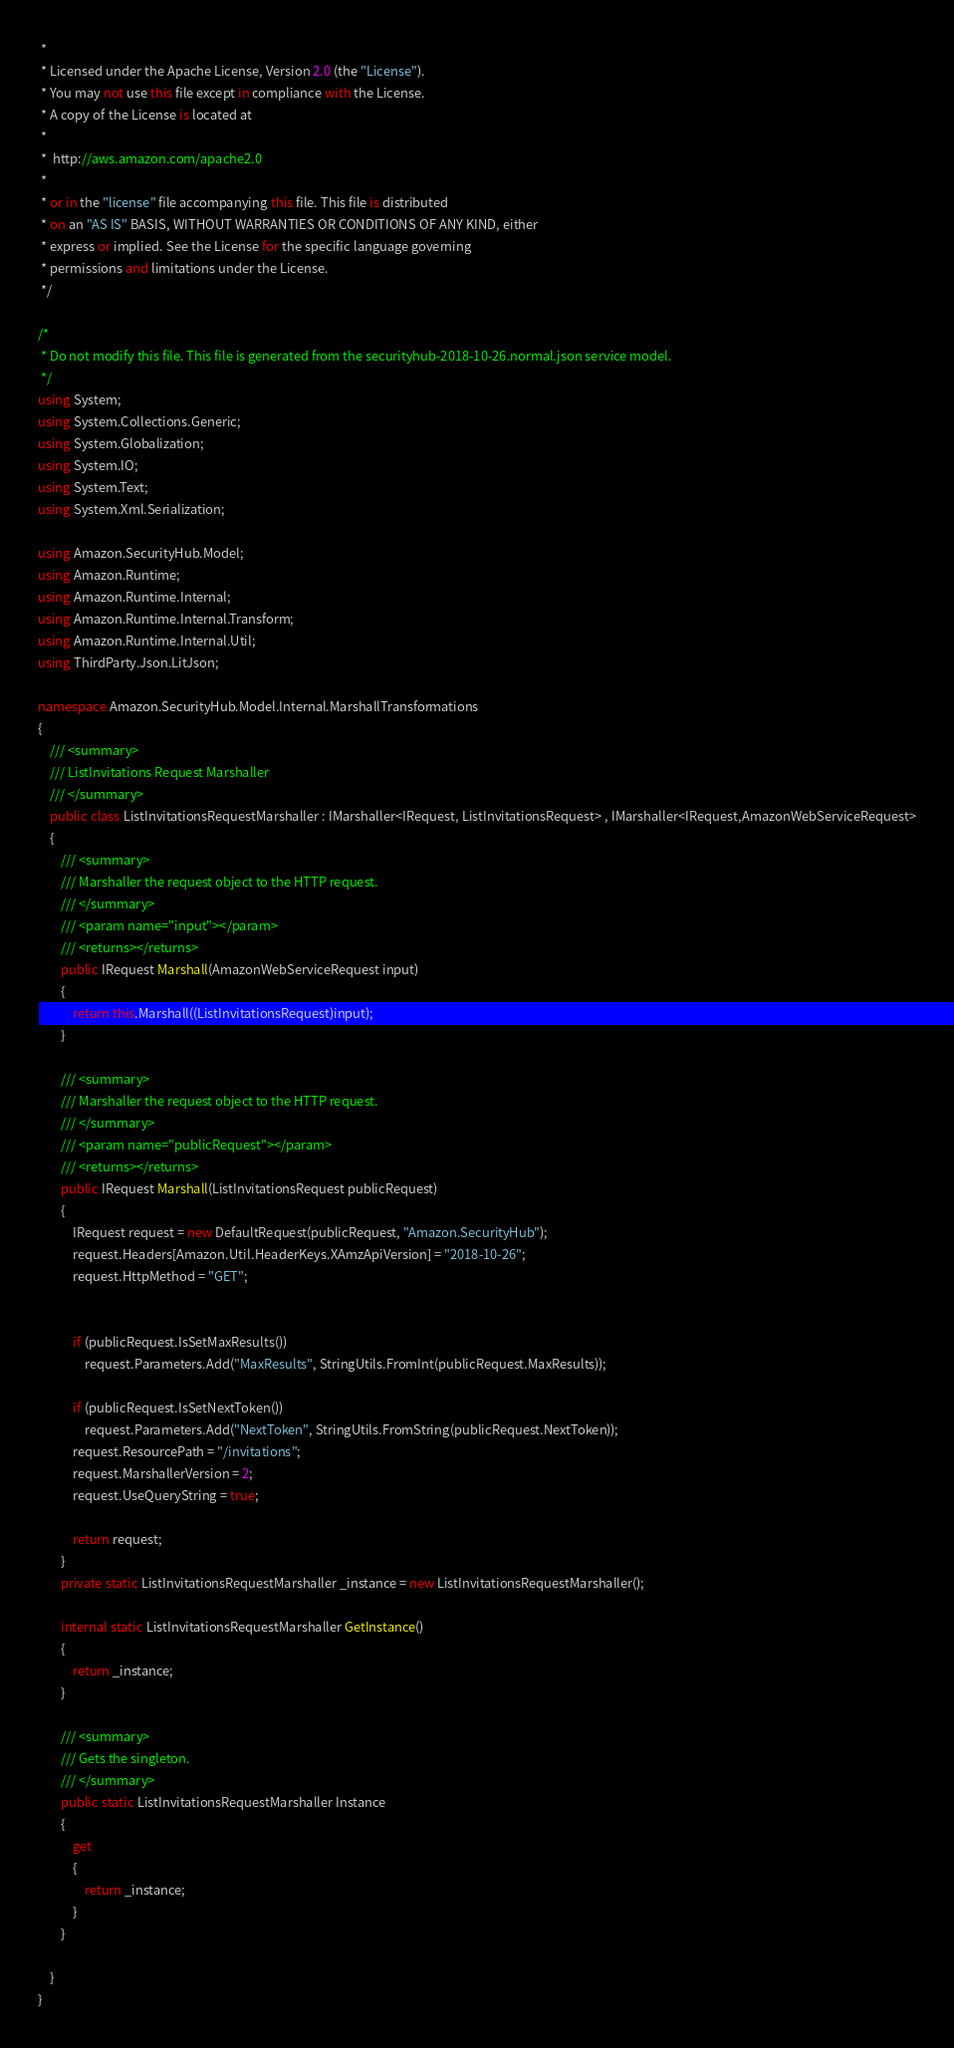Convert code to text. <code><loc_0><loc_0><loc_500><loc_500><_C#_> * 
 * Licensed under the Apache License, Version 2.0 (the "License").
 * You may not use this file except in compliance with the License.
 * A copy of the License is located at
 * 
 *  http://aws.amazon.com/apache2.0
 * 
 * or in the "license" file accompanying this file. This file is distributed
 * on an "AS IS" BASIS, WITHOUT WARRANTIES OR CONDITIONS OF ANY KIND, either
 * express or implied. See the License for the specific language governing
 * permissions and limitations under the License.
 */

/*
 * Do not modify this file. This file is generated from the securityhub-2018-10-26.normal.json service model.
 */
using System;
using System.Collections.Generic;
using System.Globalization;
using System.IO;
using System.Text;
using System.Xml.Serialization;

using Amazon.SecurityHub.Model;
using Amazon.Runtime;
using Amazon.Runtime.Internal;
using Amazon.Runtime.Internal.Transform;
using Amazon.Runtime.Internal.Util;
using ThirdParty.Json.LitJson;

namespace Amazon.SecurityHub.Model.Internal.MarshallTransformations
{
    /// <summary>
    /// ListInvitations Request Marshaller
    /// </summary>       
    public class ListInvitationsRequestMarshaller : IMarshaller<IRequest, ListInvitationsRequest> , IMarshaller<IRequest,AmazonWebServiceRequest>
    {
        /// <summary>
        /// Marshaller the request object to the HTTP request.
        /// </summary>  
        /// <param name="input"></param>
        /// <returns></returns>
        public IRequest Marshall(AmazonWebServiceRequest input)
        {
            return this.Marshall((ListInvitationsRequest)input);
        }

        /// <summary>
        /// Marshaller the request object to the HTTP request.
        /// </summary>  
        /// <param name="publicRequest"></param>
        /// <returns></returns>
        public IRequest Marshall(ListInvitationsRequest publicRequest)
        {
            IRequest request = new DefaultRequest(publicRequest, "Amazon.SecurityHub");
            request.Headers[Amazon.Util.HeaderKeys.XAmzApiVersion] = "2018-10-26";            
            request.HttpMethod = "GET";

            
            if (publicRequest.IsSetMaxResults())
                request.Parameters.Add("MaxResults", StringUtils.FromInt(publicRequest.MaxResults));
            
            if (publicRequest.IsSetNextToken())
                request.Parameters.Add("NextToken", StringUtils.FromString(publicRequest.NextToken));
            request.ResourcePath = "/invitations";
            request.MarshallerVersion = 2;
            request.UseQueryString = true;

            return request;
        }
        private static ListInvitationsRequestMarshaller _instance = new ListInvitationsRequestMarshaller();        

        internal static ListInvitationsRequestMarshaller GetInstance()
        {
            return _instance;
        }

        /// <summary>
        /// Gets the singleton.
        /// </summary>  
        public static ListInvitationsRequestMarshaller Instance
        {
            get
            {
                return _instance;
            }
        }

    }
}</code> 